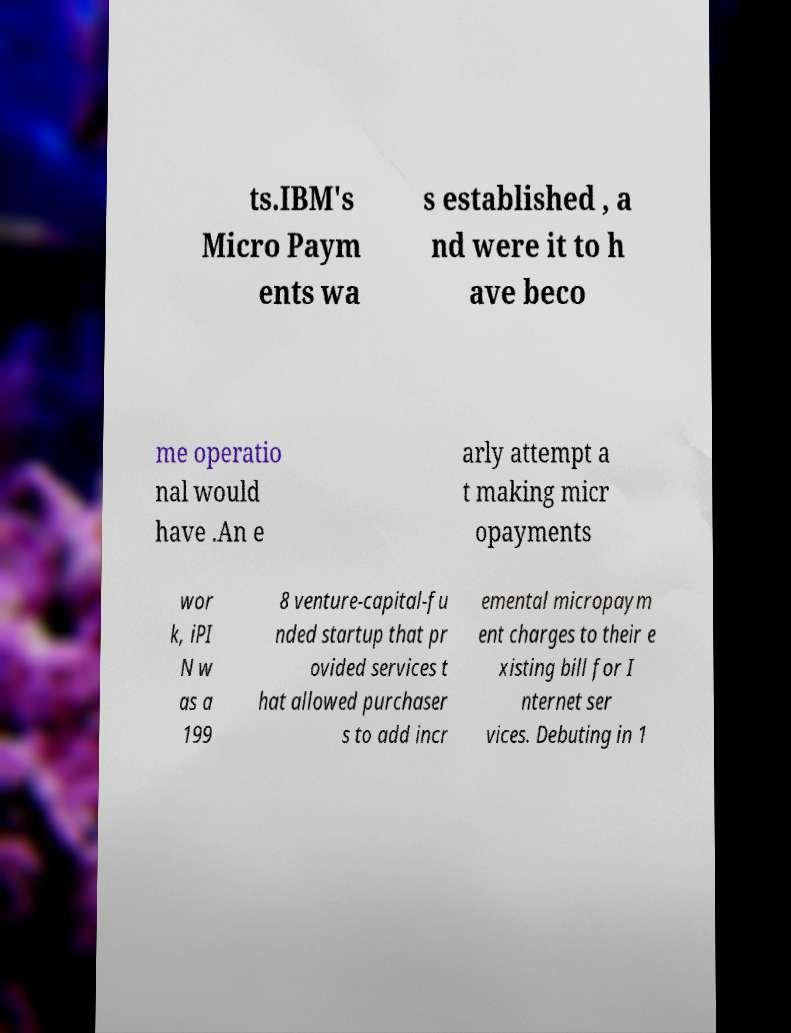There's text embedded in this image that I need extracted. Can you transcribe it verbatim? ts.IBM's Micro Paym ents wa s established , a nd were it to h ave beco me operatio nal would have .An e arly attempt a t making micr opayments wor k, iPI N w as a 199 8 venture-capital-fu nded startup that pr ovided services t hat allowed purchaser s to add incr emental micropaym ent charges to their e xisting bill for I nternet ser vices. Debuting in 1 